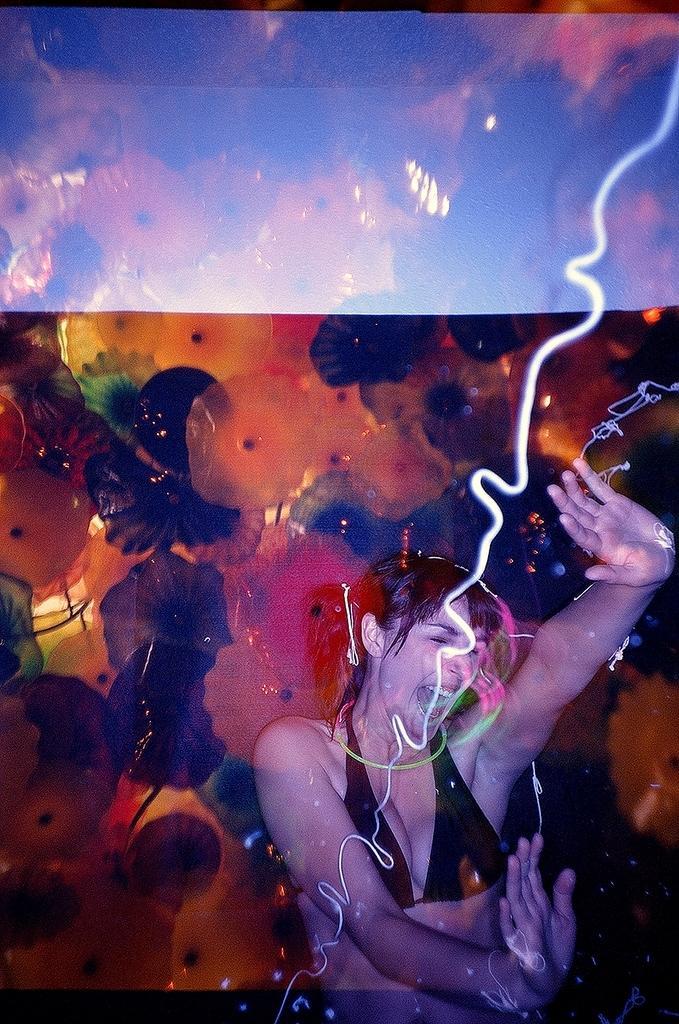In one or two sentences, can you explain what this image depicts? The image looks like an edited image. At the bottom we can see a woman dancing. At the top there are some decorative items. 